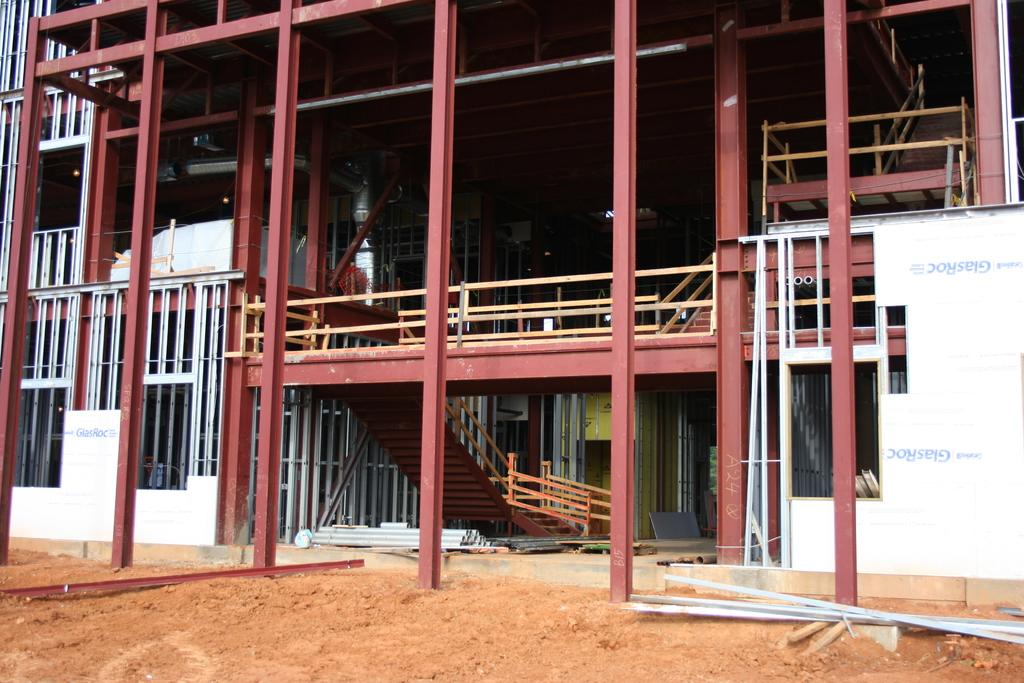What type of structure is visible in the image? There is a house in the image. What material is used to construct the house? The house is constructed with iron poles. Are there any architectural features visible in the image? Yes, there are steps and railings in the image. What is the surrounding environment like near the house? The house is near a muddy path. What color is the ink used to write on the house in the image? There is no ink or writing present on the house in the image. How does the house provide hope to the people in the image? The image does not depict any people or their emotions, so it cannot be determined how the house might provide hope. 